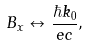<formula> <loc_0><loc_0><loc_500><loc_500>B _ { x } \leftrightarrow \frac { \hbar { k } _ { 0 } } { e c } ,</formula> 